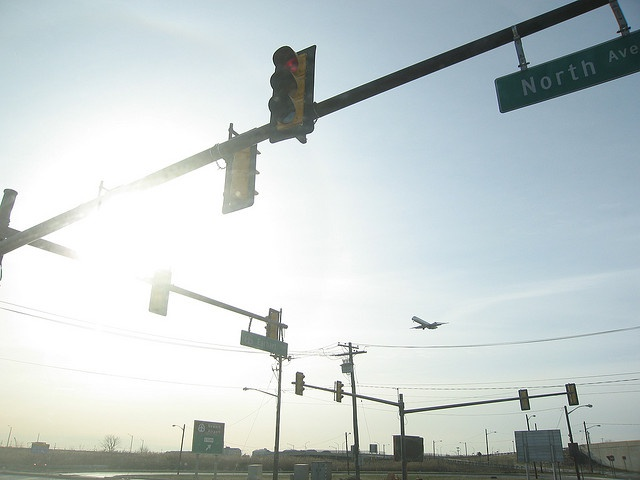Describe the objects in this image and their specific colors. I can see traffic light in darkgray, gray, and black tones, traffic light in darkgray, gray, and lightgray tones, traffic light in darkgray, ivory, beige, and lightgray tones, traffic light in darkgray, gray, and lightgray tones, and airplane in darkgray, gray, and lightgray tones in this image. 